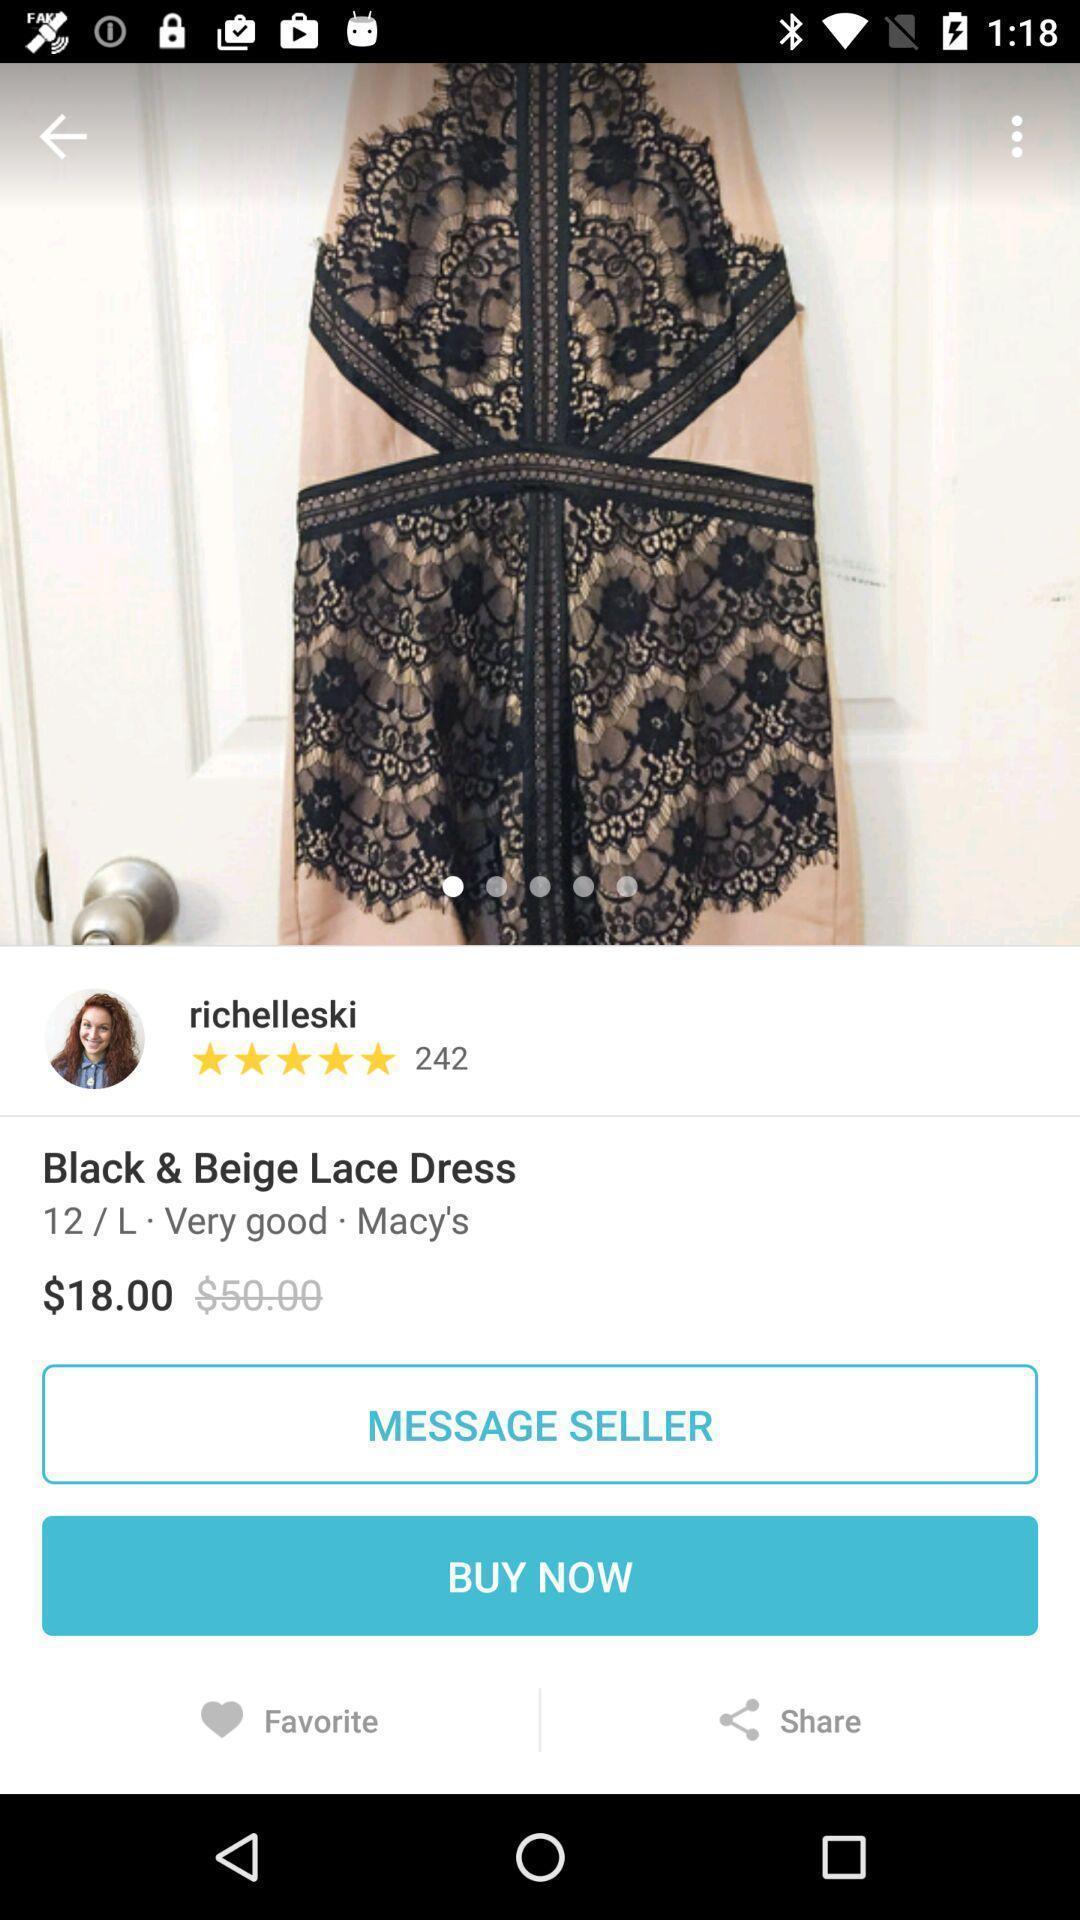What is the overall content of this screenshot? Page screen displaying searched item in shopping app. 